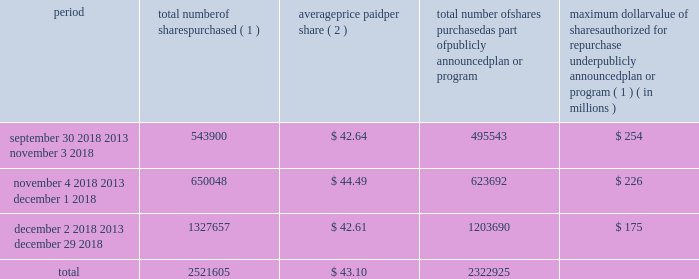Issuer purchases of equity securities in january 2017 , our board of directors authorized the repurchase of shares of our common stock with a value of up to $ 525 million in the aggregate .
As of december 29 , 2018 , $ 175 million remained available under this authorization .
In february 2019 , our board of directors authorized the additional repurchase of shares of our common stock with a value of up to $ 500.0 million in the aggregate .
The actual timing and amount of repurchases are subject to business and market conditions , corporate and regulatory requirements , stock price , acquisition opportunities and other factors .
The table presents repurchases made under our current authorization and shares surrendered by employees to satisfy income tax withholding obligations during the three months ended december 29 , 2018 : period total number of shares purchased ( 1 ) average price paid per share ( 2 ) total number of shares purchased as part of publicly announced plan or program maximum dollar value of shares authorized for repurchase under publicly announced plan or program ( 1 ) ( in millions ) september 30 , 2018 2013 november 3 , 2018 543900 $ 42.64 495543 $ 254 november 4 , 2018 2013 december 1 , 2018 650048 $ 44.49 623692 $ 226 december 2 , 2018 2013 december 29 , 2018 1327657 $ 42.61 1203690 $ 175 .
( 1 ) shares purchased that were not part of our publicly announced repurchase programs represent employee surrender of shares of restricted stock to satisfy employee income tax withholding obligations due upon vesting , and do not reduce the dollar value that may yet be purchased under our publicly announced repurchase programs .
( 2 ) the weighted average price paid per share of common stock does not include the cost of commissions. .
How is net change in cash from financing activity affected by the share repurchase during december 20018 , ( in millions ) ? 
Computations: ((1327657 * 42.61) / 1000000)
Answer: 56.57146. 